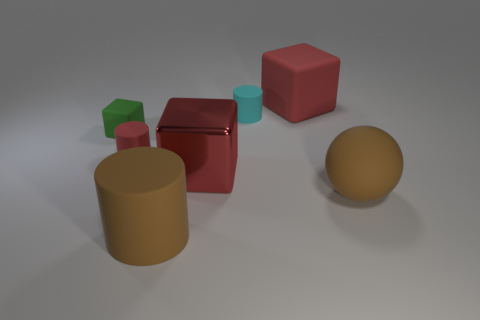Add 2 brown cylinders. How many objects exist? 9 Subtract all cubes. How many objects are left? 4 Subtract all tiny red rubber cylinders. Subtract all small rubber blocks. How many objects are left? 5 Add 3 small green rubber objects. How many small green rubber objects are left? 4 Add 7 large red matte cubes. How many large red matte cubes exist? 8 Subtract 0 gray cubes. How many objects are left? 7 